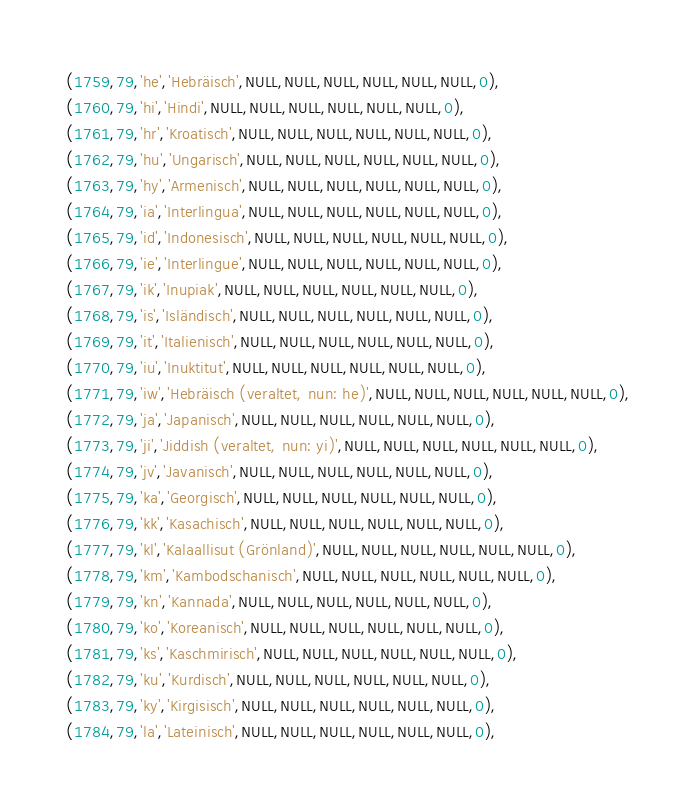<code> <loc_0><loc_0><loc_500><loc_500><_SQL_> (1759,79,'he','Hebräisch',NULL,NULL,NULL,NULL,NULL,NULL,0),
 (1760,79,'hi','Hindi',NULL,NULL,NULL,NULL,NULL,NULL,0),
 (1761,79,'hr','Kroatisch',NULL,NULL,NULL,NULL,NULL,NULL,0),
 (1762,79,'hu','Ungarisch',NULL,NULL,NULL,NULL,NULL,NULL,0),
 (1763,79,'hy','Armenisch',NULL,NULL,NULL,NULL,NULL,NULL,0),
 (1764,79,'ia','Interlingua',NULL,NULL,NULL,NULL,NULL,NULL,0),
 (1765,79,'id','Indonesisch',NULL,NULL,NULL,NULL,NULL,NULL,0),
 (1766,79,'ie','Interlingue',NULL,NULL,NULL,NULL,NULL,NULL,0),
 (1767,79,'ik','Inupiak',NULL,NULL,NULL,NULL,NULL,NULL,0),
 (1768,79,'is','Isländisch',NULL,NULL,NULL,NULL,NULL,NULL,0),
 (1769,79,'it','Italienisch',NULL,NULL,NULL,NULL,NULL,NULL,0),
 (1770,79,'iu','Inuktitut',NULL,NULL,NULL,NULL,NULL,NULL,0),
 (1771,79,'iw','Hebräisch (veraltet, nun: he)',NULL,NULL,NULL,NULL,NULL,NULL,0),
 (1772,79,'ja','Japanisch',NULL,NULL,NULL,NULL,NULL,NULL,0),
 (1773,79,'ji','Jiddish (veraltet, nun: yi)',NULL,NULL,NULL,NULL,NULL,NULL,0),
 (1774,79,'jv','Javanisch',NULL,NULL,NULL,NULL,NULL,NULL,0),
 (1775,79,'ka','Georgisch',NULL,NULL,NULL,NULL,NULL,NULL,0),
 (1776,79,'kk','Kasachisch',NULL,NULL,NULL,NULL,NULL,NULL,0),
 (1777,79,'kl','Kalaallisut (Grönland)',NULL,NULL,NULL,NULL,NULL,NULL,0),
 (1778,79,'km','Kambodschanisch',NULL,NULL,NULL,NULL,NULL,NULL,0),
 (1779,79,'kn','Kannada',NULL,NULL,NULL,NULL,NULL,NULL,0),
 (1780,79,'ko','Koreanisch',NULL,NULL,NULL,NULL,NULL,NULL,0),
 (1781,79,'ks','Kaschmirisch',NULL,NULL,NULL,NULL,NULL,NULL,0),
 (1782,79,'ku','Kurdisch',NULL,NULL,NULL,NULL,NULL,NULL,0),
 (1783,79,'ky','Kirgisisch',NULL,NULL,NULL,NULL,NULL,NULL,0),
 (1784,79,'la','Lateinisch',NULL,NULL,NULL,NULL,NULL,NULL,0),</code> 